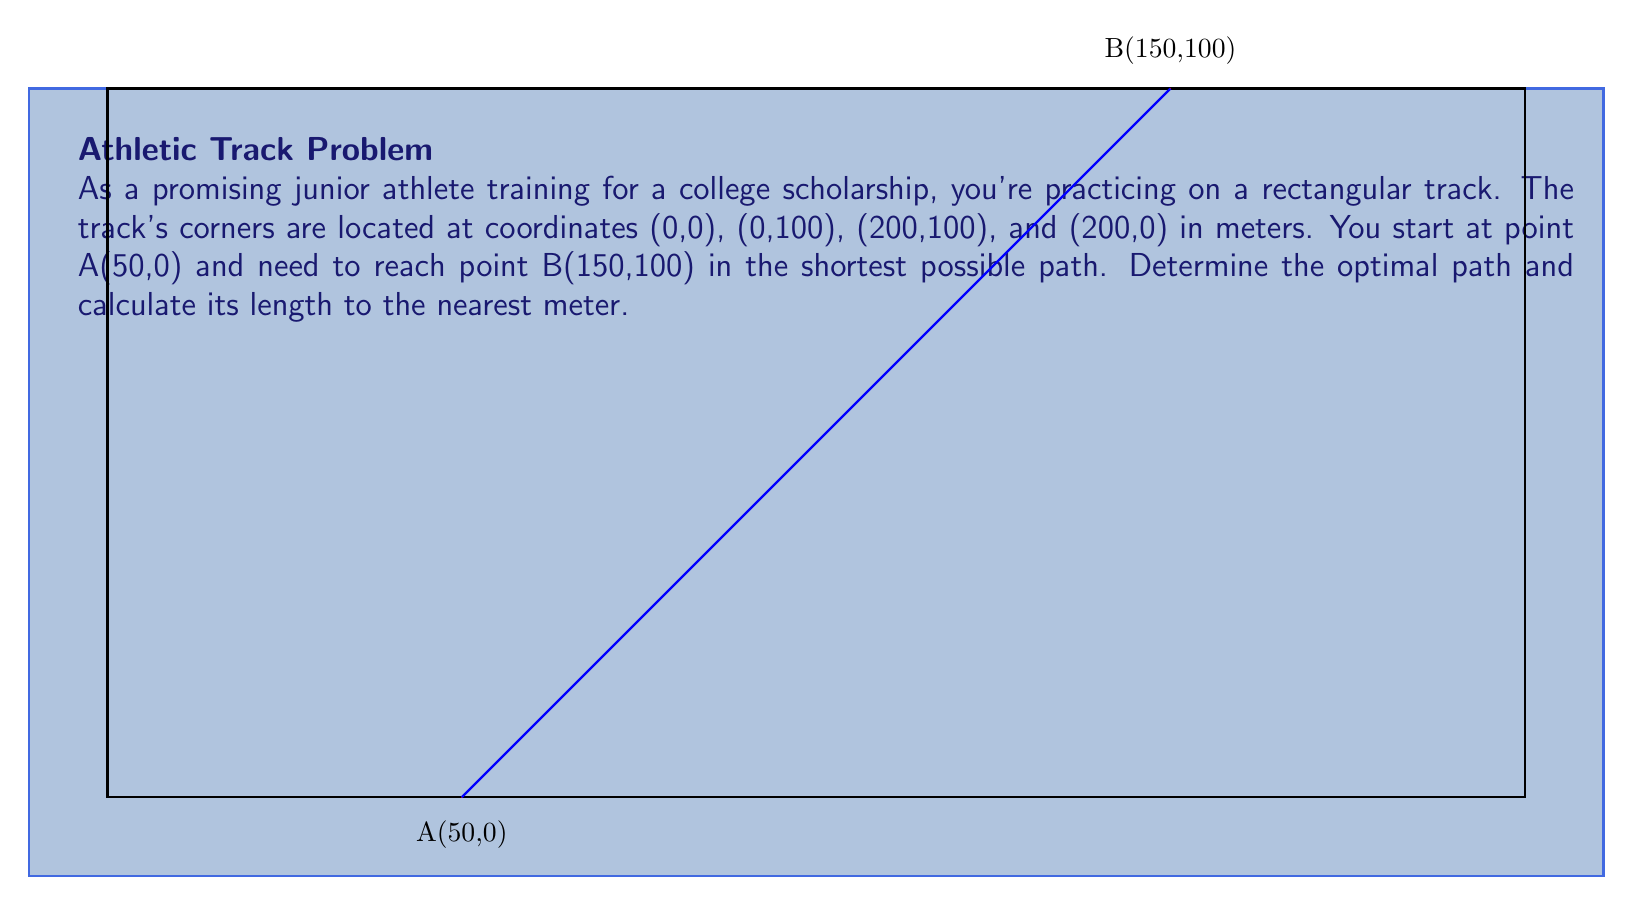Show me your answer to this math problem. To solve this problem, we'll follow these steps:

1) The optimal path between two points is always a straight line. Therefore, the shortest path from A to B is a straight line connecting these points.

2) To calculate the length of this path, we can use the distance formula:

   $$d = \sqrt{(x_2-x_1)^2 + (y_2-y_1)^2}$$

   where $(x_1,y_1)$ is the starting point and $(x_2,y_2)$ is the ending point.

3) We have:
   A(50,0) and B(150,100)
   So, $(x_1,y_1) = (50,0)$ and $(x_2,y_2) = (150,100)$

4) Let's substitute these into the formula:

   $$d = \sqrt{(150-50)^2 + (100-0)^2}$$

5) Simplify:
   $$d = \sqrt{100^2 + 100^2} = \sqrt{10000 + 10000} = \sqrt{20000}$$

6) Calculate:
   $$d = \sqrt{20000} \approx 141.4214 \text{ meters}$$

7) Rounding to the nearest meter:
   $$d \approx 141 \text{ meters}$$

Therefore, the optimal path is a straight line from A to B, with a length of approximately 141 meters.
Answer: 141 meters 